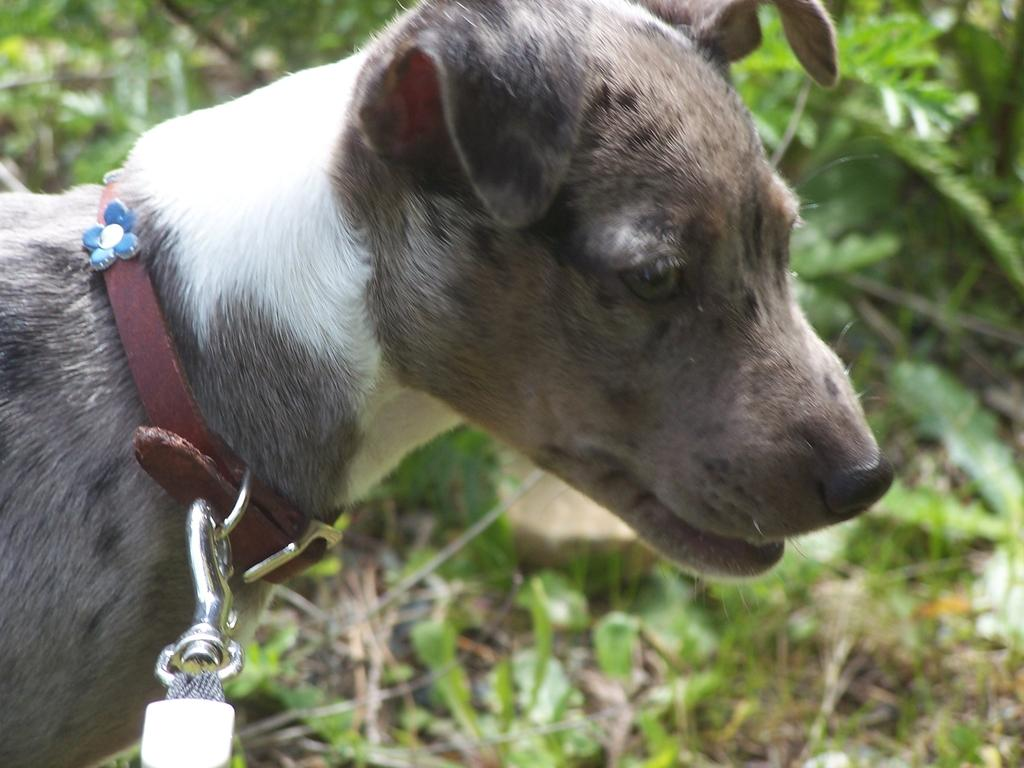Where was the image taken? The image is taken outdoors. What type of surface is visible in the image? There is a ground with grass in the image. What else can be seen on the ground? There are plants on the ground. What animal is on the left side of the image? There is a dog on the left side of the image. What color is the silver bird flying in the image? There is no silver bird present in the image. 